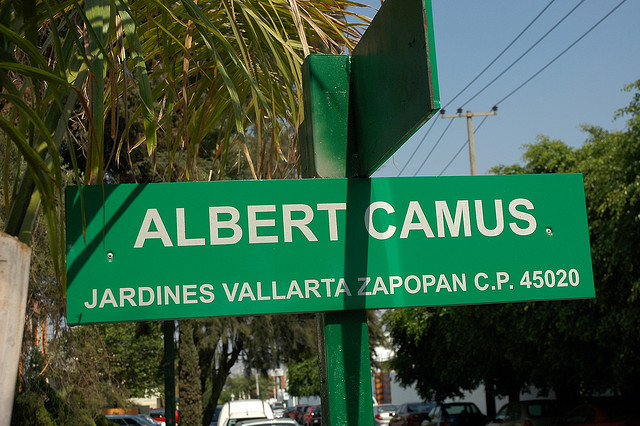Identify the text contained in this image. ALBERT CAMUS VALLARTA ZAPOPAN 45020 C.P. JARDINES 